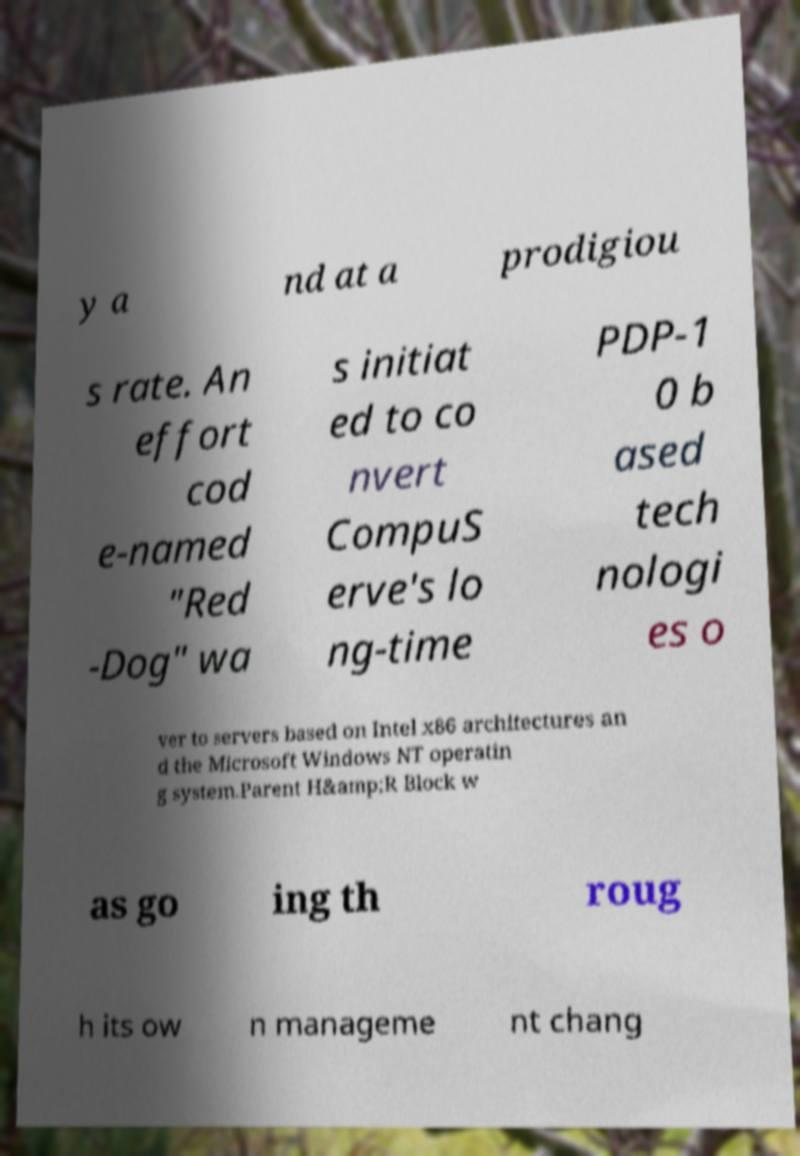For documentation purposes, I need the text within this image transcribed. Could you provide that? y a nd at a prodigiou s rate. An effort cod e-named "Red -Dog" wa s initiat ed to co nvert CompuS erve's lo ng-time PDP-1 0 b ased tech nologi es o ver to servers based on Intel x86 architectures an d the Microsoft Windows NT operatin g system.Parent H&amp;R Block w as go ing th roug h its ow n manageme nt chang 